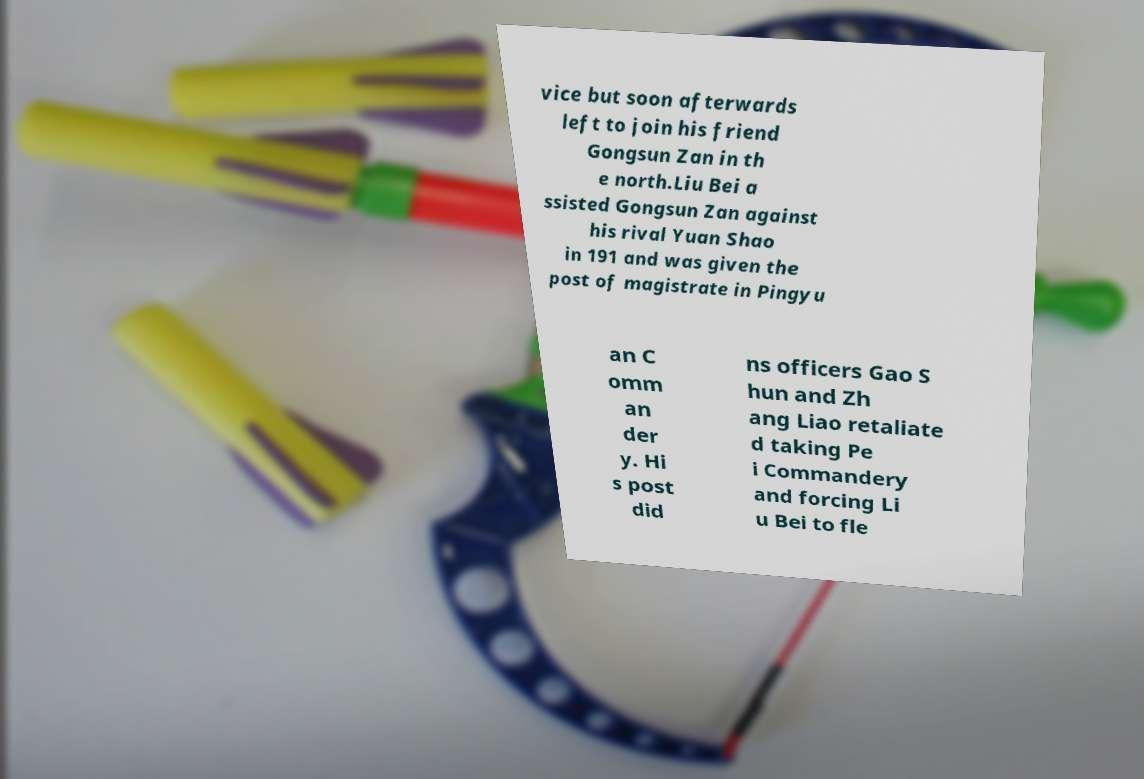Please read and relay the text visible in this image. What does it say? vice but soon afterwards left to join his friend Gongsun Zan in th e north.Liu Bei a ssisted Gongsun Zan against his rival Yuan Shao in 191 and was given the post of magistrate in Pingyu an C omm an der y. Hi s post did ns officers Gao S hun and Zh ang Liao retaliate d taking Pe i Commandery and forcing Li u Bei to fle 